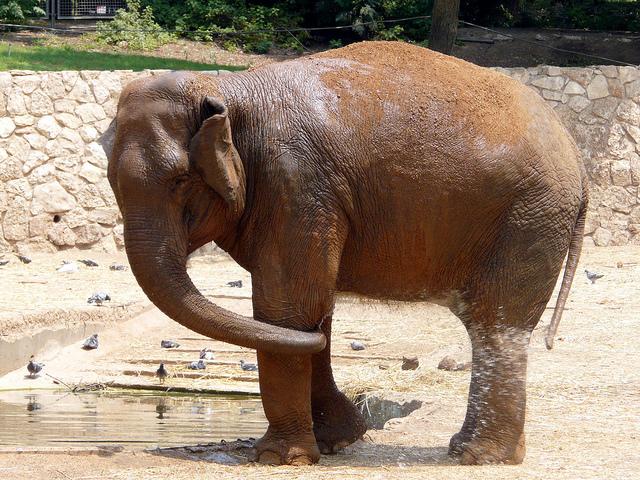Are there other animals near this elephant?
Write a very short answer. Yes. How long is the elephant's trunk?
Answer briefly. Long. What does this animal appear to be doing?
Be succinct. Bathing. 